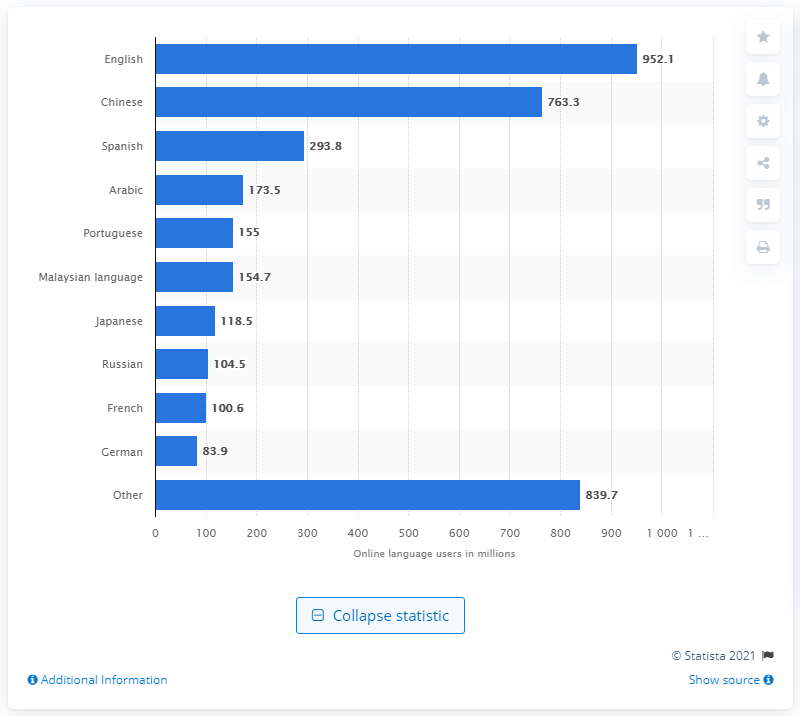What was the most popular language online as of March 2017?
 English 